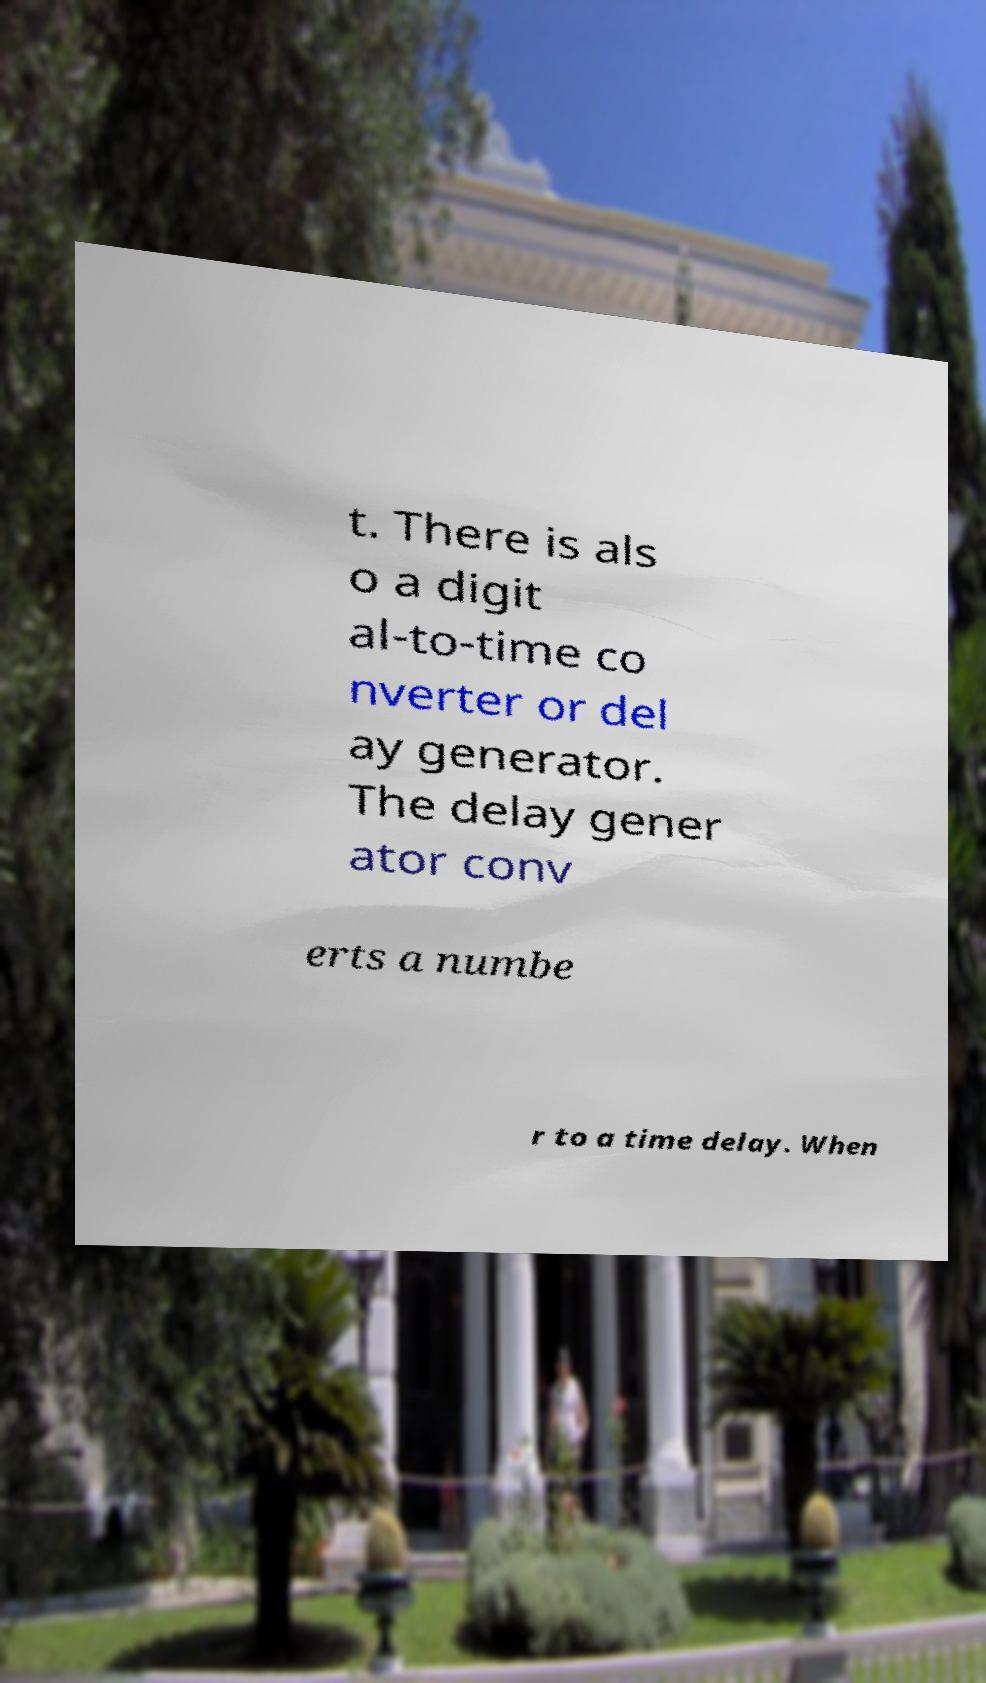Please identify and transcribe the text found in this image. t. There is als o a digit al-to-time co nverter or del ay generator. The delay gener ator conv erts a numbe r to a time delay. When 